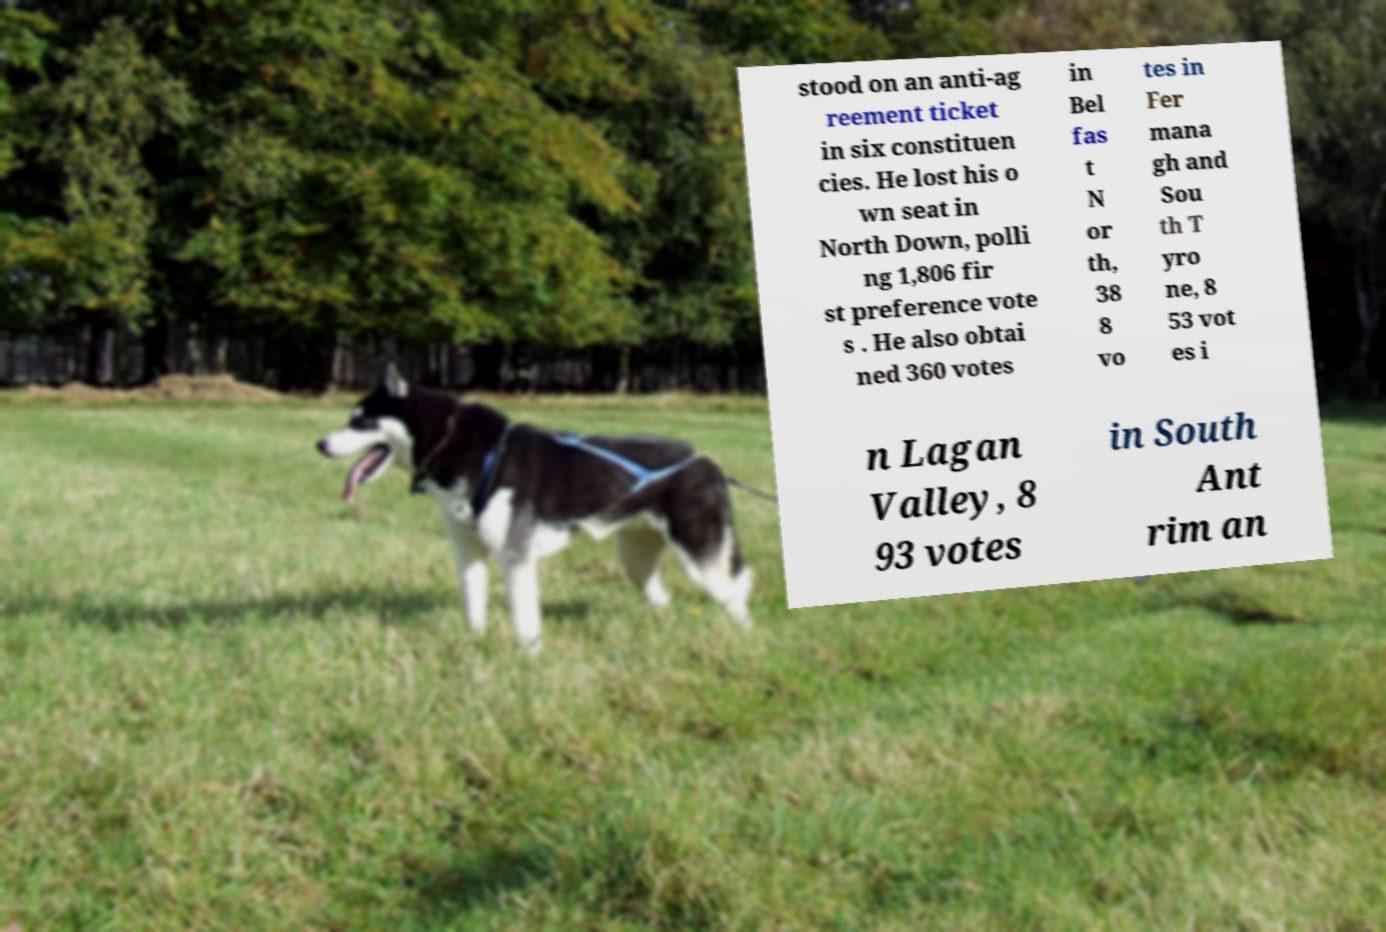Please identify and transcribe the text found in this image. stood on an anti-ag reement ticket in six constituen cies. He lost his o wn seat in North Down, polli ng 1,806 fir st preference vote s . He also obtai ned 360 votes in Bel fas t N or th, 38 8 vo tes in Fer mana gh and Sou th T yro ne, 8 53 vot es i n Lagan Valley, 8 93 votes in South Ant rim an 